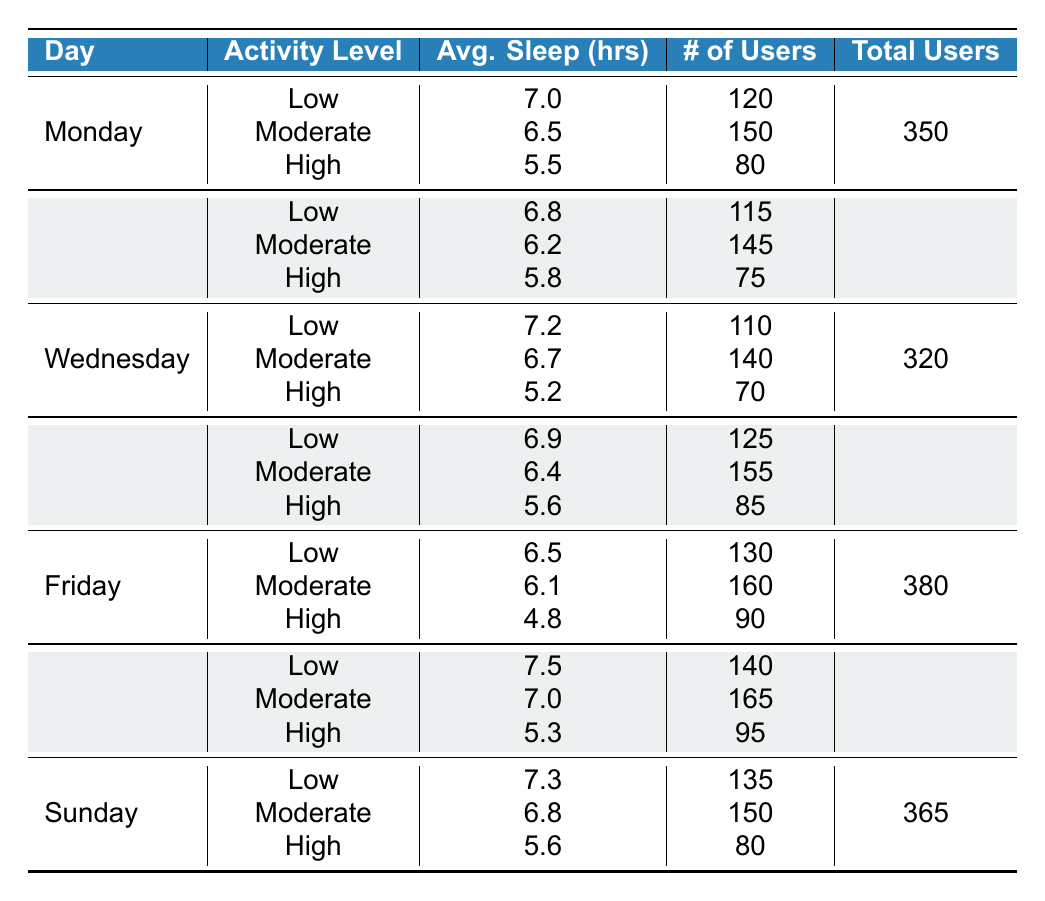What is the average sleep hours for users with a low activity level on Friday? Referring to the table, on Friday, the average sleep hours for users with a low activity level is 6.5.
Answer: 6.5 What day of the week shows the highest average sleep hours for users with moderate activity levels? Checking the table for moderate activity levels: Monday has 6.5, Tuesday has 6.2, Wednesday has 6.7, Thursday has 6.4, Friday has 6.1, Saturday has 7.0, and Sunday has 6.8. The highest average is on Saturday with 7.0.
Answer: Saturday Is there a user activity level that consistently has the lowest average sleep hours across all days? By checking each day for high activity levels, we see: Monday 5.5, Tuesday 5.8, Wednesday 5.2, Thursday 5.6, Friday 4.8, Saturday 5.3, and Sunday 5.6. Friday has the overall lowest average sleep hours at 4.8 for high activity level users.
Answer: Yes Calculate the total number of users who reported their sleep patterns on Wednesday. The total number of users for each activity level on Wednesday are as follows: Low 110, Moderate 140, High 70. Adding these gives 110 + 140 + 70 = 320 users.
Answer: 320 What was the average sleep hours for all users with a low activity level throughout the week? For low activity users: Monday 7.0, Tuesday 6.8, Wednesday 7.2, Thursday 6.9, Friday 6.5, Saturday 7.5, Sunday 7.3. Summing these hours gives 7.0 + 6.8 + 7.2 + 6.9 + 6.5 + 7.5 + 7.3 = 49.2. Dividing 49.2 by the 7 days gives an average of 49.2 / 7 ≈ 7.0.
Answer: 7.0 On which day are users classified as having a moderate activity level most numerous? Looking at the table, the number of users for moderate activity level is: Monday 150, Tuesday 145, Wednesday 140, Thursday 155, Friday 160, Saturday 165, Sunday 150. The highest number is on Saturday with 165 users.
Answer: Saturday Is the average sleep for users with a high activity level higher on Tuesday than on Thursday? Evaluating the averages: High on Tuesday is 5.8 and on Thursday is 5.6. Since 5.8 is greater than 5.6, it confirms that the average for Tuesday is indeed higher.
Answer: Yes What is the difference in average sleep hours between low and high activity levels on Sunday? For Sunday, low activity average is 7.3 and high activity average is 5.6. The difference is calculated as 7.3 - 5.6 = 1.7 hours.
Answer: 1.7 Which day had the highest total number of users participating in sleep monitoring? By summing the total users for each day: Monday 350, Tuesday 335, Wednesday 320, Thursday 365, Friday 380, Saturday 400, Sunday 365. The highest total is on Saturday with 400 users.
Answer: Saturday 